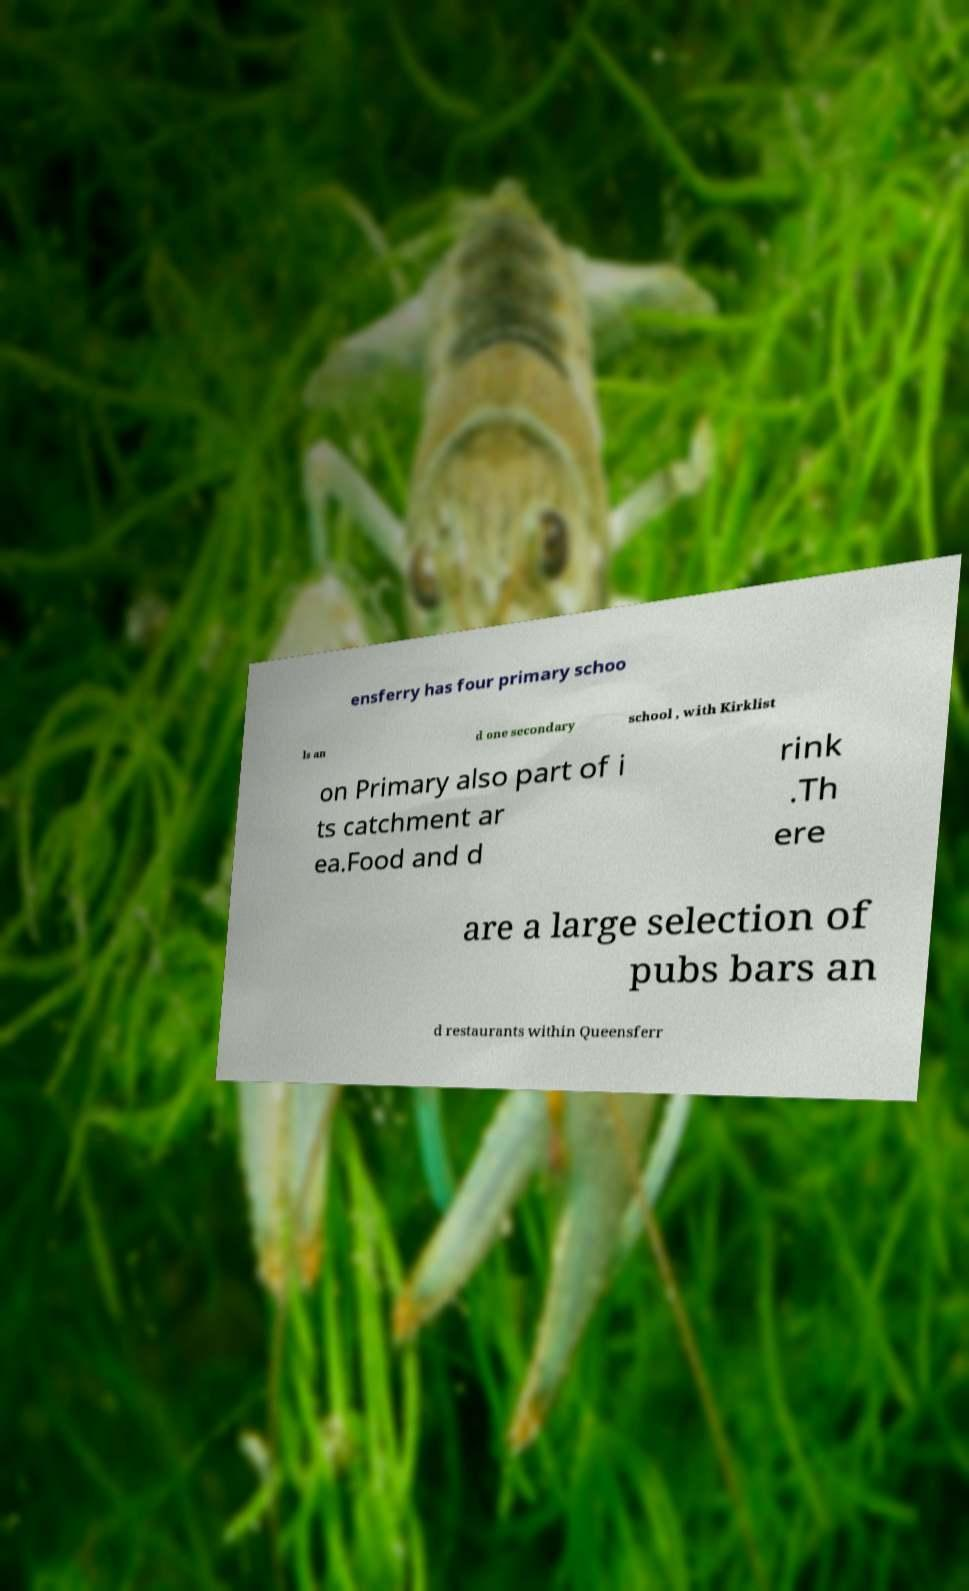What messages or text are displayed in this image? I need them in a readable, typed format. ensferry has four primary schoo ls an d one secondary school , with Kirklist on Primary also part of i ts catchment ar ea.Food and d rink .Th ere are a large selection of pubs bars an d restaurants within Queensferr 